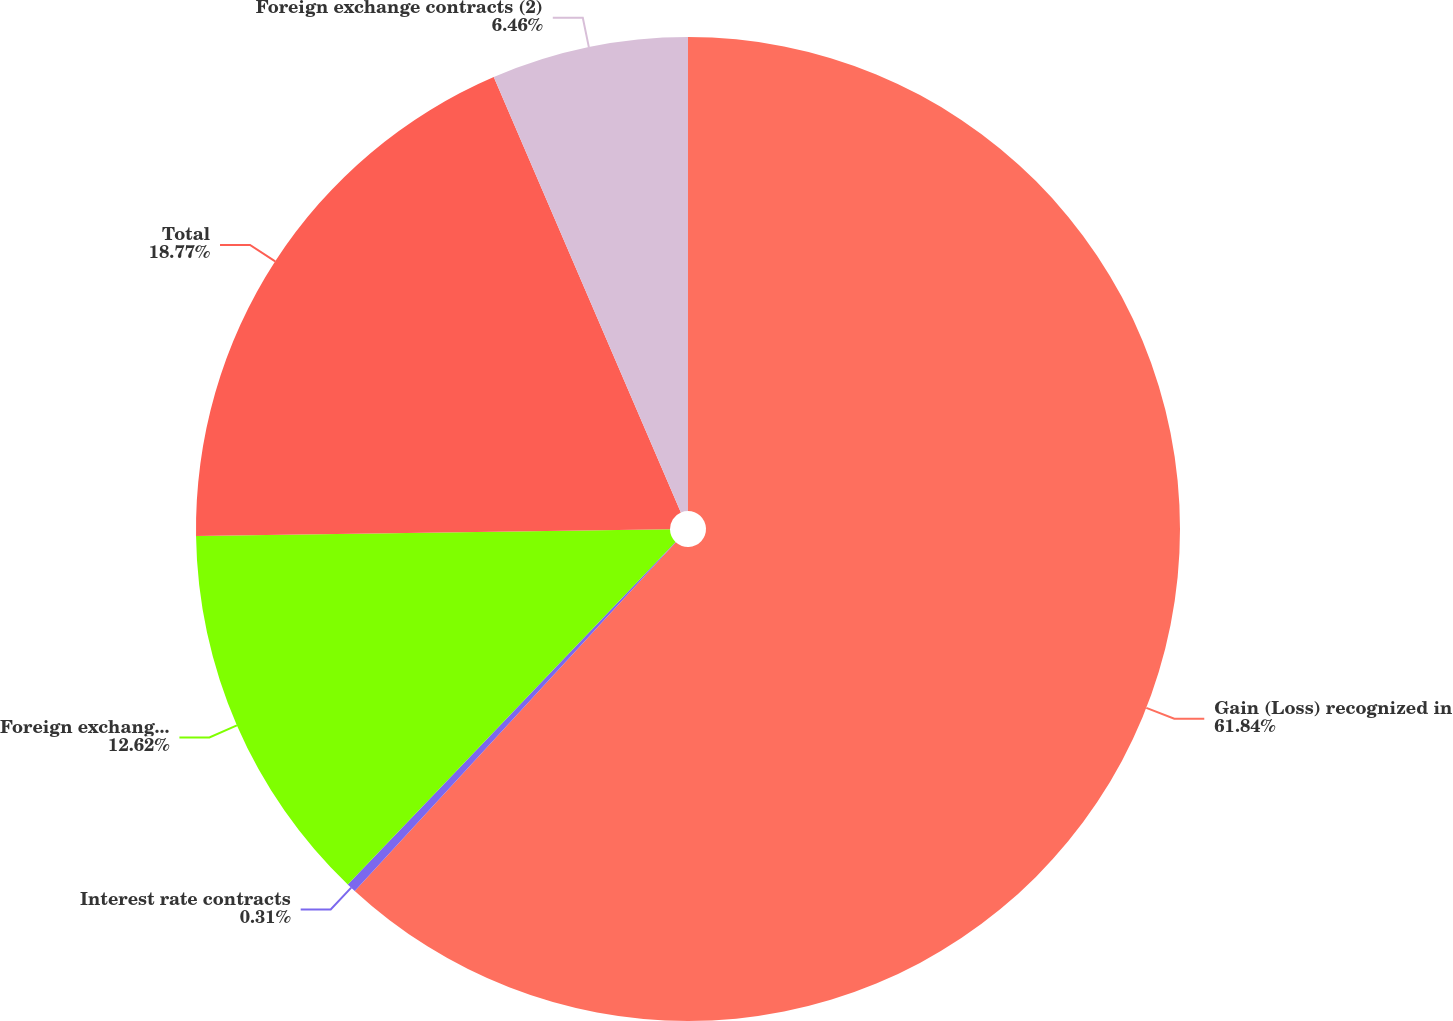Convert chart to OTSL. <chart><loc_0><loc_0><loc_500><loc_500><pie_chart><fcel>Gain (Loss) recognized in<fcel>Interest rate contracts<fcel>Foreign exchange contracts<fcel>Total<fcel>Foreign exchange contracts (2)<nl><fcel>61.85%<fcel>0.31%<fcel>12.62%<fcel>18.77%<fcel>6.46%<nl></chart> 